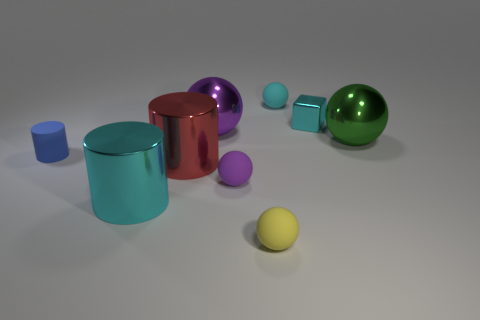What number of tiny matte things have the same shape as the large purple metal thing?
Your answer should be compact. 3. There is a small purple object that is the same material as the tiny blue thing; what is its shape?
Ensure brevity in your answer.  Sphere. What is the material of the cyan thing left of the purple sphere that is in front of the purple sphere on the left side of the small purple object?
Make the answer very short. Metal. Do the green object and the thing that is behind the tiny cyan cube have the same size?
Provide a succinct answer. No. There is a red object that is the same shape as the tiny blue matte thing; what is its material?
Your answer should be very brief. Metal. What is the size of the purple ball that is behind the purple thing that is in front of the red thing that is to the left of the small yellow ball?
Your response must be concise. Large. Is the size of the green sphere the same as the cyan rubber ball?
Provide a short and direct response. No. What material is the small cyan object that is to the right of the small thing that is behind the block?
Your answer should be compact. Metal. Is the shape of the cyan thing in front of the tiny rubber cylinder the same as the purple thing in front of the red cylinder?
Ensure brevity in your answer.  No. Are there the same number of yellow spheres that are to the right of the small blue cylinder and cyan metal objects?
Make the answer very short. No. 